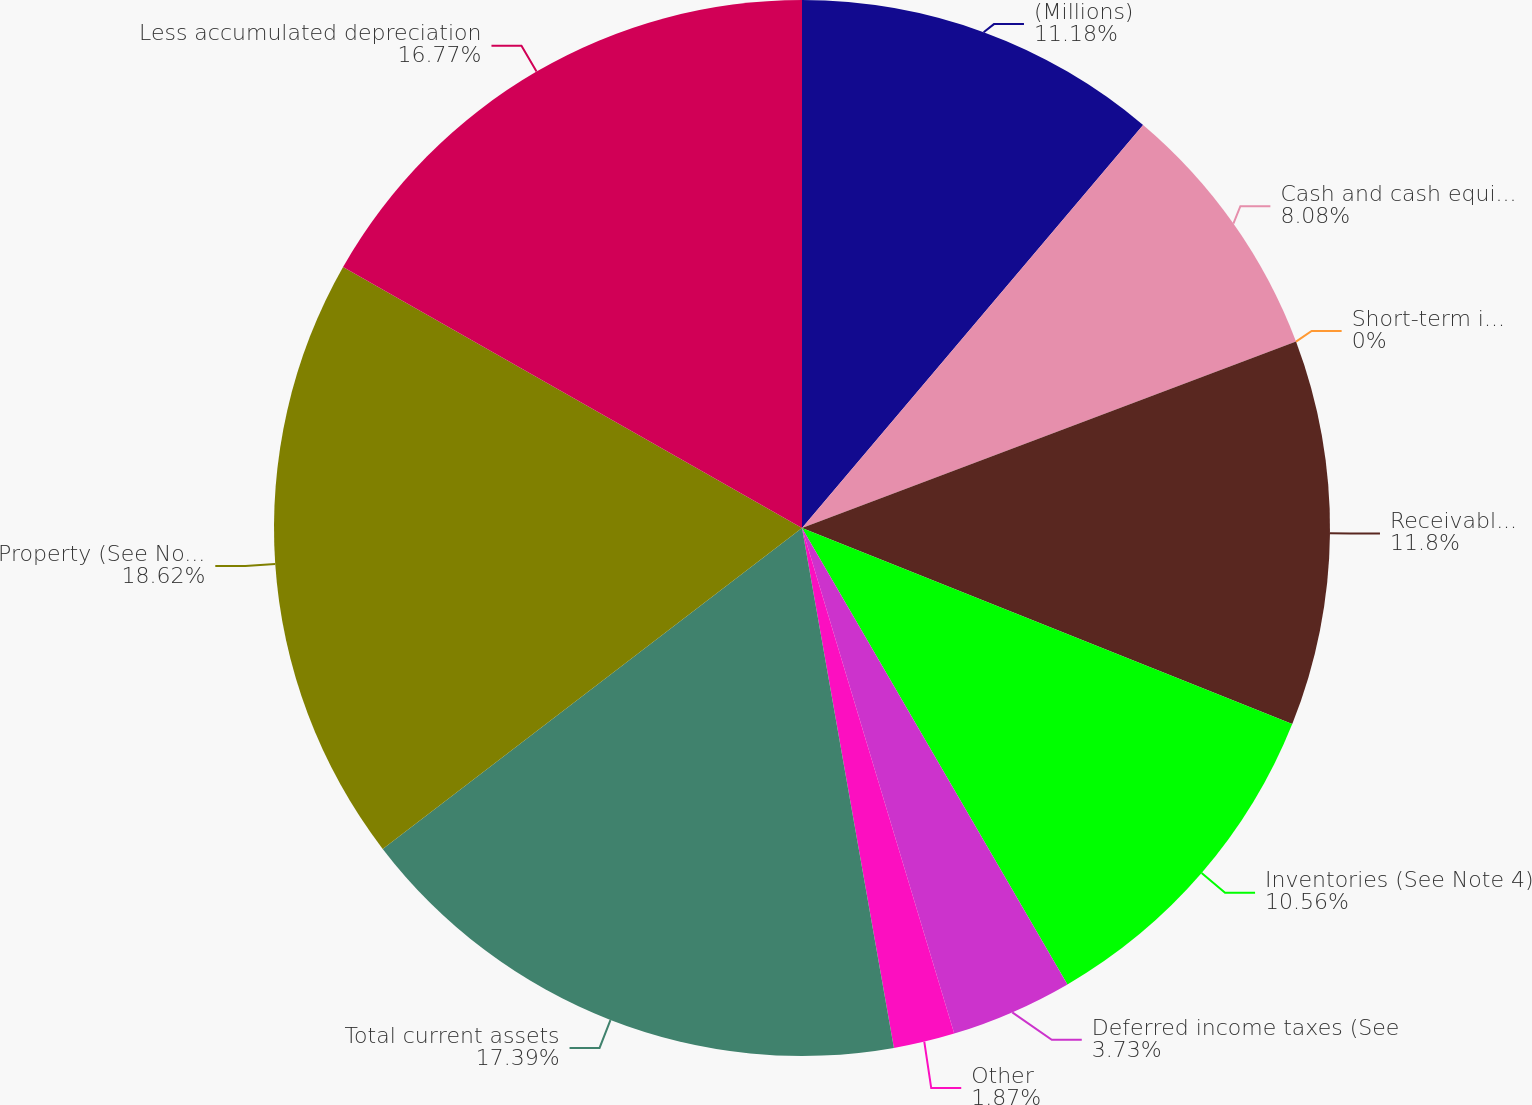<chart> <loc_0><loc_0><loc_500><loc_500><pie_chart><fcel>(Millions)<fcel>Cash and cash equivalents<fcel>Short-term investments (See<fcel>Receivables (See Note 4)<fcel>Inventories (See Note 4)<fcel>Deferred income taxes (See<fcel>Other<fcel>Total current assets<fcel>Property (See Note 5)<fcel>Less accumulated depreciation<nl><fcel>11.18%<fcel>8.08%<fcel>0.0%<fcel>11.8%<fcel>10.56%<fcel>3.73%<fcel>1.87%<fcel>17.39%<fcel>18.63%<fcel>16.77%<nl></chart> 